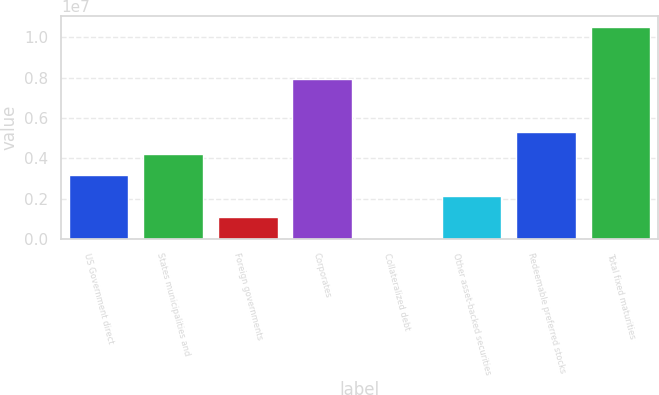Convert chart to OTSL. <chart><loc_0><loc_0><loc_500><loc_500><bar_chart><fcel>US Government direct<fcel>States municipalities and<fcel>Foreign governments<fcel>Corporates<fcel>Collateralized debt<fcel>Other asset-backed securities<fcel>Redeemable preferred stocks<fcel>Total fixed maturities<nl><fcel>3.17863e+06<fcel>4.23069e+06<fcel>1.07451e+06<fcel>7.92086e+06<fcel>22456<fcel>2.12657e+06<fcel>5.28274e+06<fcel>1.0543e+07<nl></chart> 